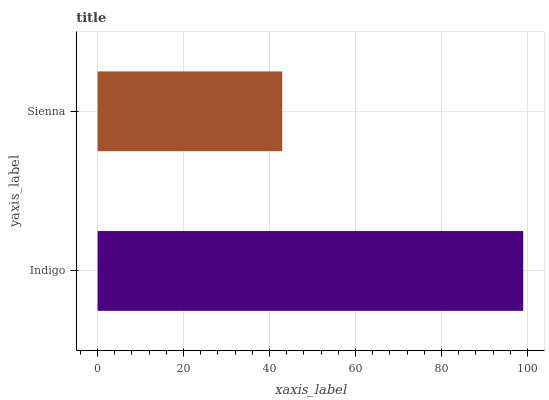Is Sienna the minimum?
Answer yes or no. Yes. Is Indigo the maximum?
Answer yes or no. Yes. Is Sienna the maximum?
Answer yes or no. No. Is Indigo greater than Sienna?
Answer yes or no. Yes. Is Sienna less than Indigo?
Answer yes or no. Yes. Is Sienna greater than Indigo?
Answer yes or no. No. Is Indigo less than Sienna?
Answer yes or no. No. Is Indigo the high median?
Answer yes or no. Yes. Is Sienna the low median?
Answer yes or no. Yes. Is Sienna the high median?
Answer yes or no. No. Is Indigo the low median?
Answer yes or no. No. 